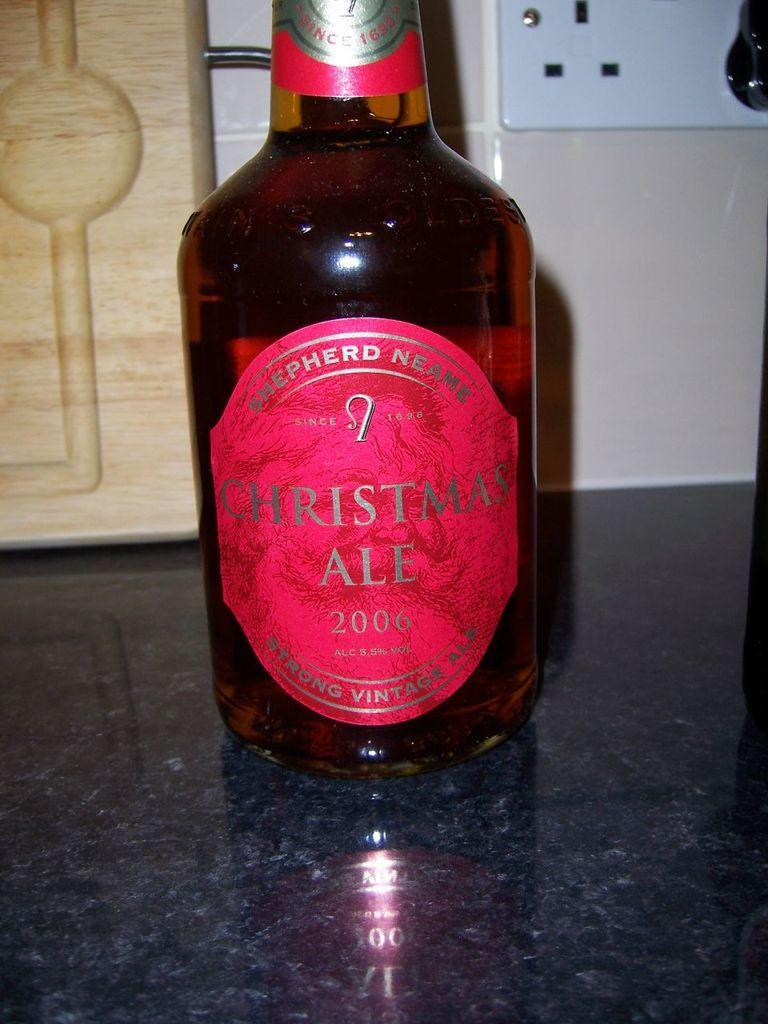<image>
Relay a brief, clear account of the picture shown. Shepherd Neame Christmas Ale in a bottle from 2006 